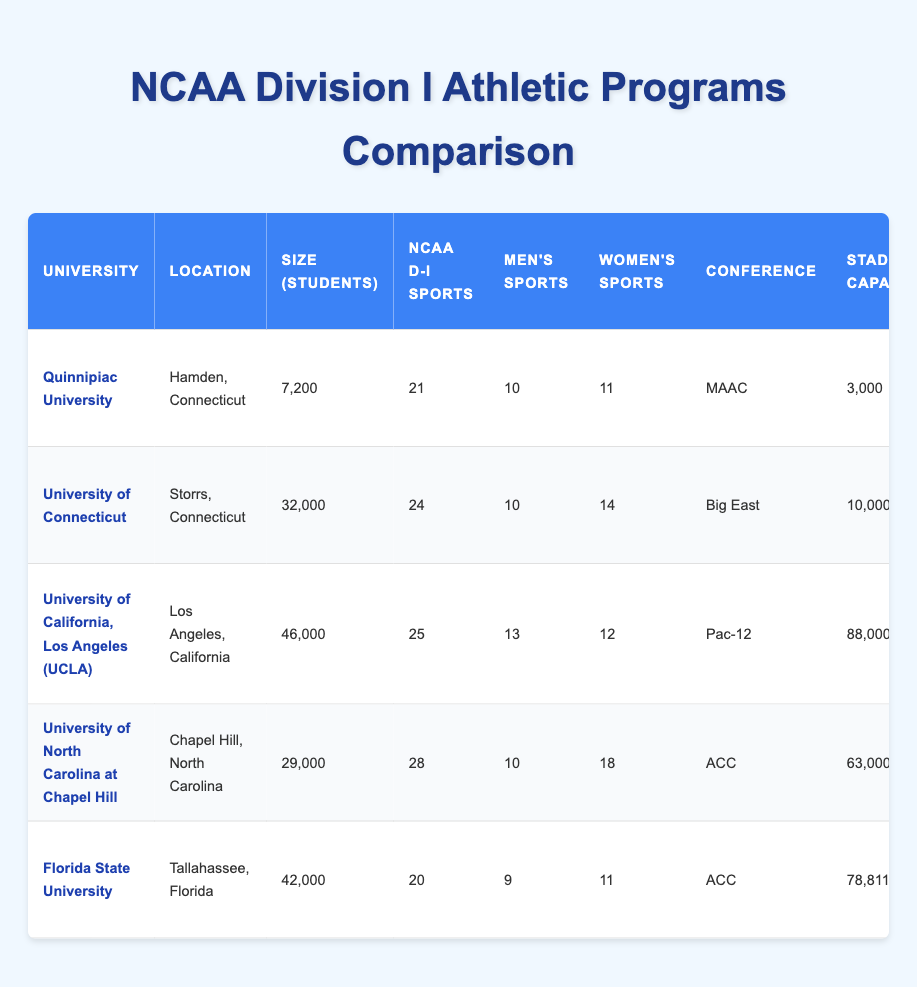What is the university size (number of students) for Quinnipiac University? According to the table, Quinnipiac University has a student enrollment of 7,200.
Answer: 7,200 How many NCAA Division I sports does the University of North Carolina at Chapel Hill have? The table indicates that the University of North Carolina at Chapel Hill has 28 NCAA Division I sports.
Answer: 28 Which university has the largest stadium capacity? The table shows that the University of California, Los Angeles (UCLA) has a stadium capacity of 88,000, which is the highest among the listed universities.
Answer: UCLA (88,000) How many men's sports are offered at Quinnipiac University? The table lists that Quinnipiac University offers 10 men's sports.
Answer: 10 What is the difference in the number of national championships won between UCLA and Quinnipiac University? UCLA has won 118 national championships, while Quinnipiac University has won 1. Thus, the difference is 118 - 1 = 117.
Answer: 117 Which universities are in the ACC conference? The table indicates that the universities in the ACC conference are the University of North Carolina at Chapel Hill and Florida State University.
Answer: UNC and Florida State Is it true that Florida State University has a larger number of NCAA Division I sports than Quinnipiac University? Florida State University has 20 NCAA Division I sports, while Quinnipiac University has 21, making this statement false.
Answer: No What is the average number of national championships won by the universities listed? Adding the national championships won: 1 (Quinnipiac) + 17 (UConn) + 118 (UCLA) + 48 (UNC) + 16 (Florida State) = 200. There are 5 universities, so the average is 200 / 5 = 40.
Answer: 40 Which university has the highest number of women's sports, and how many are offered? The table states that the University of North Carolina at Chapel Hill has the highest number of women's sports at 18.
Answer: UNC (18) Are there more men's or women's sports at the University of Connecticut? The table shows that the University of Connecticut has 10 men's sports and 14 women's sports; therefore, there are more women's sports.
Answer: Women's sports What year was Quinnipiac University established, and how old is it as of 2023? Quinnipiac University was established in 1929. As of 2023, it is 2023 - 1929 = 94 years old.
Answer: 94 years old 